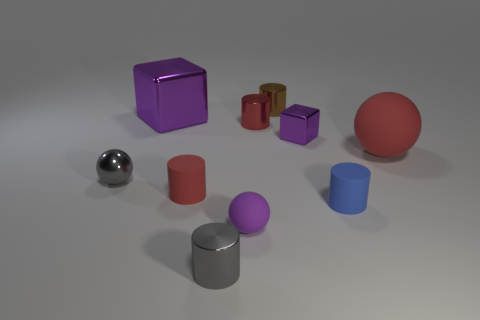Does the gray thing that is in front of the metallic sphere have the same size as the tiny purple block?
Your response must be concise. Yes. The big object on the right side of the small red cylinder that is in front of the cube that is in front of the big purple block is made of what material?
Give a very brief answer. Rubber. There is a rubber ball that is in front of the big matte thing; is its color the same as the cylinder that is in front of the small blue rubber object?
Your answer should be very brief. No. What is the material of the purple thing behind the purple cube right of the big purple metal thing?
Ensure brevity in your answer.  Metal. What is the color of the block that is the same size as the gray cylinder?
Provide a succinct answer. Purple. Does the tiny blue matte object have the same shape as the large purple metal object in front of the tiny brown object?
Keep it short and to the point. No. There is a small thing that is the same color as the tiny metallic ball; what shape is it?
Offer a terse response. Cylinder. What number of gray metal cylinders are behind the red cylinder behind the big object that is on the right side of the red shiny object?
Your response must be concise. 0. There is a cube in front of the purple metal cube left of the small rubber sphere; what size is it?
Offer a very short reply. Small. What is the size of the red cylinder that is made of the same material as the small brown object?
Keep it short and to the point. Small. 